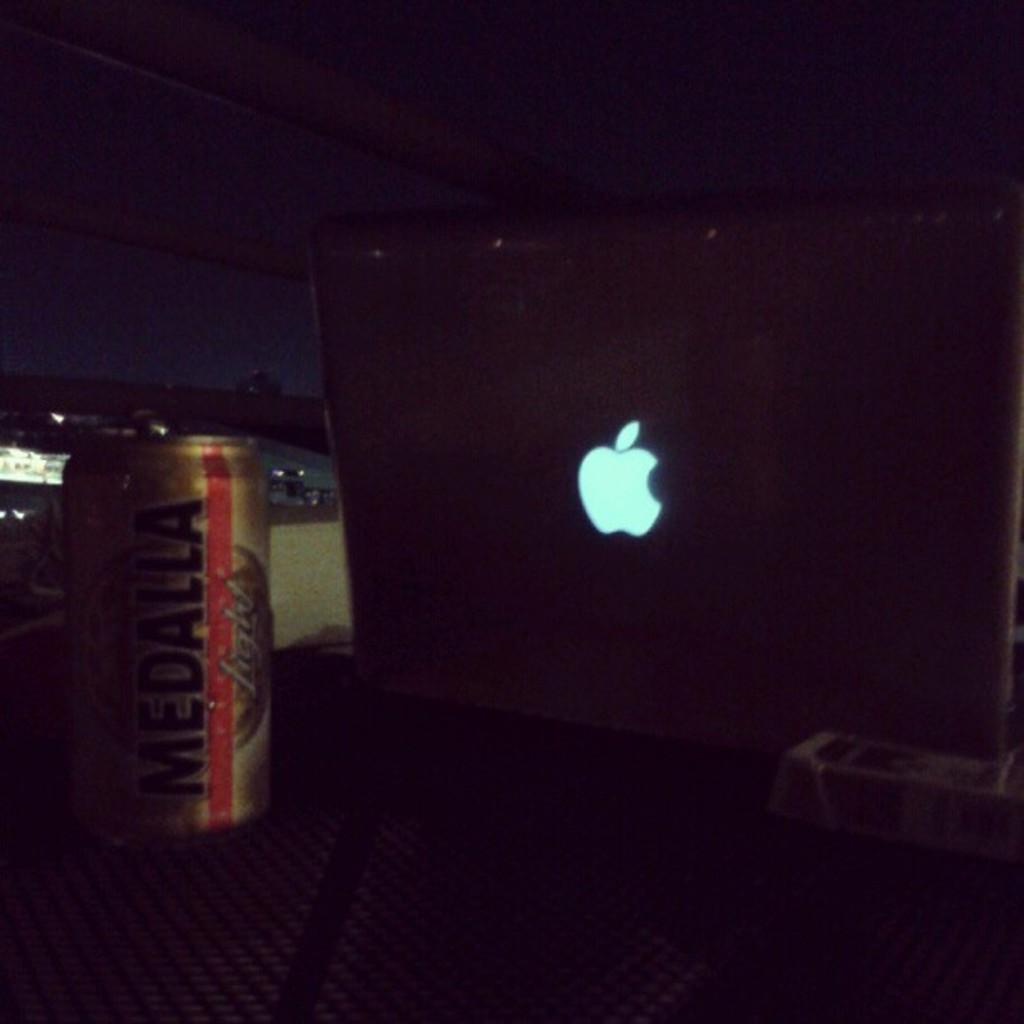Provide a one-sentence caption for the provided image. A Medalla drink sits next to an Apple laptop computer. 